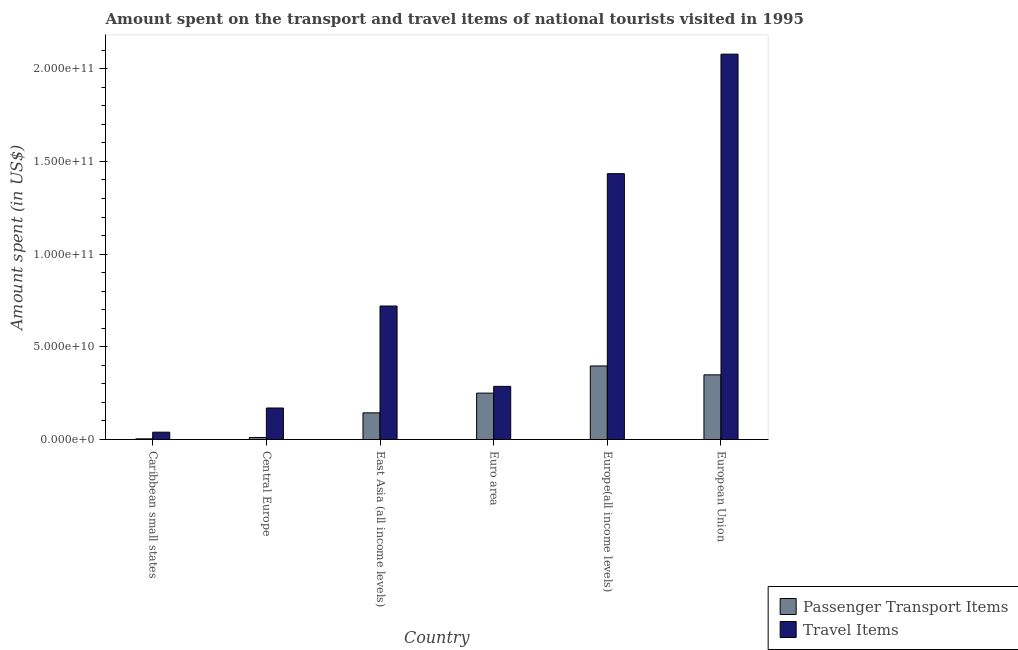How many different coloured bars are there?
Offer a terse response. 2. Are the number of bars per tick equal to the number of legend labels?
Your answer should be very brief. Yes. In how many cases, is the number of bars for a given country not equal to the number of legend labels?
Provide a succinct answer. 0. What is the amount spent in travel items in European Union?
Offer a terse response. 2.08e+11. Across all countries, what is the maximum amount spent on passenger transport items?
Give a very brief answer. 3.97e+1. Across all countries, what is the minimum amount spent in travel items?
Offer a terse response. 3.96e+09. In which country was the amount spent on passenger transport items maximum?
Provide a succinct answer. Europe(all income levels). In which country was the amount spent in travel items minimum?
Offer a terse response. Caribbean small states. What is the total amount spent on passenger transport items in the graph?
Give a very brief answer. 1.15e+11. What is the difference between the amount spent on passenger transport items in Caribbean small states and that in Central Europe?
Your response must be concise. -7.48e+08. What is the difference between the amount spent on passenger transport items in Euro area and the amount spent in travel items in Central Europe?
Offer a very short reply. 8.04e+09. What is the average amount spent in travel items per country?
Your response must be concise. 7.88e+1. What is the difference between the amount spent on passenger transport items and amount spent in travel items in European Union?
Your answer should be compact. -1.73e+11. In how many countries, is the amount spent in travel items greater than 130000000000 US$?
Ensure brevity in your answer.  2. What is the ratio of the amount spent in travel items in East Asia (all income levels) to that in Euro area?
Ensure brevity in your answer.  2.51. Is the difference between the amount spent in travel items in Central Europe and Euro area greater than the difference between the amount spent on passenger transport items in Central Europe and Euro area?
Ensure brevity in your answer.  Yes. What is the difference between the highest and the second highest amount spent in travel items?
Your answer should be compact. 6.45e+1. What is the difference between the highest and the lowest amount spent on passenger transport items?
Your answer should be very brief. 3.93e+1. What does the 1st bar from the left in East Asia (all income levels) represents?
Your answer should be very brief. Passenger Transport Items. What does the 2nd bar from the right in European Union represents?
Offer a terse response. Passenger Transport Items. How many bars are there?
Your answer should be very brief. 12. How many countries are there in the graph?
Offer a terse response. 6. What is the difference between two consecutive major ticks on the Y-axis?
Provide a short and direct response. 5.00e+1. Does the graph contain any zero values?
Offer a terse response. No. Does the graph contain grids?
Make the answer very short. No. Where does the legend appear in the graph?
Offer a terse response. Bottom right. How many legend labels are there?
Provide a succinct answer. 2. How are the legend labels stacked?
Your answer should be compact. Vertical. What is the title of the graph?
Your response must be concise. Amount spent on the transport and travel items of national tourists visited in 1995. What is the label or title of the Y-axis?
Your answer should be very brief. Amount spent (in US$). What is the Amount spent (in US$) in Passenger Transport Items in Caribbean small states?
Give a very brief answer. 3.62e+08. What is the Amount spent (in US$) in Travel Items in Caribbean small states?
Offer a terse response. 3.96e+09. What is the Amount spent (in US$) in Passenger Transport Items in Central Europe?
Keep it short and to the point. 1.11e+09. What is the Amount spent (in US$) in Travel Items in Central Europe?
Ensure brevity in your answer.  1.70e+1. What is the Amount spent (in US$) of Passenger Transport Items in East Asia (all income levels)?
Provide a succinct answer. 1.44e+1. What is the Amount spent (in US$) of Travel Items in East Asia (all income levels)?
Give a very brief answer. 7.20e+1. What is the Amount spent (in US$) of Passenger Transport Items in Euro area?
Ensure brevity in your answer.  2.50e+1. What is the Amount spent (in US$) in Travel Items in Euro area?
Keep it short and to the point. 2.87e+1. What is the Amount spent (in US$) in Passenger Transport Items in Europe(all income levels)?
Your answer should be compact. 3.97e+1. What is the Amount spent (in US$) of Travel Items in Europe(all income levels)?
Your response must be concise. 1.43e+11. What is the Amount spent (in US$) in Passenger Transport Items in European Union?
Give a very brief answer. 3.49e+1. What is the Amount spent (in US$) in Travel Items in European Union?
Your answer should be very brief. 2.08e+11. Across all countries, what is the maximum Amount spent (in US$) in Passenger Transport Items?
Keep it short and to the point. 3.97e+1. Across all countries, what is the maximum Amount spent (in US$) of Travel Items?
Make the answer very short. 2.08e+11. Across all countries, what is the minimum Amount spent (in US$) of Passenger Transport Items?
Offer a very short reply. 3.62e+08. Across all countries, what is the minimum Amount spent (in US$) in Travel Items?
Offer a terse response. 3.96e+09. What is the total Amount spent (in US$) of Passenger Transport Items in the graph?
Your answer should be very brief. 1.15e+11. What is the total Amount spent (in US$) in Travel Items in the graph?
Provide a succinct answer. 4.73e+11. What is the difference between the Amount spent (in US$) of Passenger Transport Items in Caribbean small states and that in Central Europe?
Offer a terse response. -7.48e+08. What is the difference between the Amount spent (in US$) of Travel Items in Caribbean small states and that in Central Europe?
Offer a terse response. -1.30e+1. What is the difference between the Amount spent (in US$) of Passenger Transport Items in Caribbean small states and that in East Asia (all income levels)?
Your answer should be very brief. -1.40e+1. What is the difference between the Amount spent (in US$) of Travel Items in Caribbean small states and that in East Asia (all income levels)?
Make the answer very short. -6.81e+1. What is the difference between the Amount spent (in US$) of Passenger Transport Items in Caribbean small states and that in Euro area?
Provide a succinct answer. -2.47e+1. What is the difference between the Amount spent (in US$) of Travel Items in Caribbean small states and that in Euro area?
Keep it short and to the point. -2.47e+1. What is the difference between the Amount spent (in US$) of Passenger Transport Items in Caribbean small states and that in Europe(all income levels)?
Provide a succinct answer. -3.93e+1. What is the difference between the Amount spent (in US$) of Travel Items in Caribbean small states and that in Europe(all income levels)?
Your answer should be compact. -1.39e+11. What is the difference between the Amount spent (in US$) of Passenger Transport Items in Caribbean small states and that in European Union?
Provide a succinct answer. -3.45e+1. What is the difference between the Amount spent (in US$) in Travel Items in Caribbean small states and that in European Union?
Your answer should be very brief. -2.04e+11. What is the difference between the Amount spent (in US$) in Passenger Transport Items in Central Europe and that in East Asia (all income levels)?
Offer a terse response. -1.33e+1. What is the difference between the Amount spent (in US$) in Travel Items in Central Europe and that in East Asia (all income levels)?
Offer a very short reply. -5.50e+1. What is the difference between the Amount spent (in US$) of Passenger Transport Items in Central Europe and that in Euro area?
Keep it short and to the point. -2.39e+1. What is the difference between the Amount spent (in US$) in Travel Items in Central Europe and that in Euro area?
Make the answer very short. -1.17e+1. What is the difference between the Amount spent (in US$) in Passenger Transport Items in Central Europe and that in Europe(all income levels)?
Offer a terse response. -3.86e+1. What is the difference between the Amount spent (in US$) in Travel Items in Central Europe and that in Europe(all income levels)?
Offer a terse response. -1.26e+11. What is the difference between the Amount spent (in US$) in Passenger Transport Items in Central Europe and that in European Union?
Offer a terse response. -3.38e+1. What is the difference between the Amount spent (in US$) in Travel Items in Central Europe and that in European Union?
Make the answer very short. -1.91e+11. What is the difference between the Amount spent (in US$) of Passenger Transport Items in East Asia (all income levels) and that in Euro area?
Your answer should be compact. -1.06e+1. What is the difference between the Amount spent (in US$) in Travel Items in East Asia (all income levels) and that in Euro area?
Give a very brief answer. 4.33e+1. What is the difference between the Amount spent (in US$) of Passenger Transport Items in East Asia (all income levels) and that in Europe(all income levels)?
Your answer should be compact. -2.53e+1. What is the difference between the Amount spent (in US$) in Travel Items in East Asia (all income levels) and that in Europe(all income levels)?
Make the answer very short. -7.14e+1. What is the difference between the Amount spent (in US$) of Passenger Transport Items in East Asia (all income levels) and that in European Union?
Ensure brevity in your answer.  -2.05e+1. What is the difference between the Amount spent (in US$) of Travel Items in East Asia (all income levels) and that in European Union?
Keep it short and to the point. -1.36e+11. What is the difference between the Amount spent (in US$) of Passenger Transport Items in Euro area and that in Europe(all income levels)?
Keep it short and to the point. -1.47e+1. What is the difference between the Amount spent (in US$) in Travel Items in Euro area and that in Europe(all income levels)?
Offer a very short reply. -1.15e+11. What is the difference between the Amount spent (in US$) of Passenger Transport Items in Euro area and that in European Union?
Offer a very short reply. -9.85e+09. What is the difference between the Amount spent (in US$) of Travel Items in Euro area and that in European Union?
Ensure brevity in your answer.  -1.79e+11. What is the difference between the Amount spent (in US$) of Passenger Transport Items in Europe(all income levels) and that in European Union?
Offer a terse response. 4.80e+09. What is the difference between the Amount spent (in US$) of Travel Items in Europe(all income levels) and that in European Union?
Provide a succinct answer. -6.45e+1. What is the difference between the Amount spent (in US$) in Passenger Transport Items in Caribbean small states and the Amount spent (in US$) in Travel Items in Central Europe?
Ensure brevity in your answer.  -1.66e+1. What is the difference between the Amount spent (in US$) in Passenger Transport Items in Caribbean small states and the Amount spent (in US$) in Travel Items in East Asia (all income levels)?
Ensure brevity in your answer.  -7.16e+1. What is the difference between the Amount spent (in US$) in Passenger Transport Items in Caribbean small states and the Amount spent (in US$) in Travel Items in Euro area?
Your response must be concise. -2.83e+1. What is the difference between the Amount spent (in US$) in Passenger Transport Items in Caribbean small states and the Amount spent (in US$) in Travel Items in Europe(all income levels)?
Your answer should be very brief. -1.43e+11. What is the difference between the Amount spent (in US$) in Passenger Transport Items in Caribbean small states and the Amount spent (in US$) in Travel Items in European Union?
Provide a short and direct response. -2.08e+11. What is the difference between the Amount spent (in US$) in Passenger Transport Items in Central Europe and the Amount spent (in US$) in Travel Items in East Asia (all income levels)?
Offer a very short reply. -7.09e+1. What is the difference between the Amount spent (in US$) of Passenger Transport Items in Central Europe and the Amount spent (in US$) of Travel Items in Euro area?
Offer a very short reply. -2.76e+1. What is the difference between the Amount spent (in US$) of Passenger Transport Items in Central Europe and the Amount spent (in US$) of Travel Items in Europe(all income levels)?
Make the answer very short. -1.42e+11. What is the difference between the Amount spent (in US$) of Passenger Transport Items in Central Europe and the Amount spent (in US$) of Travel Items in European Union?
Keep it short and to the point. -2.07e+11. What is the difference between the Amount spent (in US$) in Passenger Transport Items in East Asia (all income levels) and the Amount spent (in US$) in Travel Items in Euro area?
Your answer should be compact. -1.43e+1. What is the difference between the Amount spent (in US$) in Passenger Transport Items in East Asia (all income levels) and the Amount spent (in US$) in Travel Items in Europe(all income levels)?
Offer a terse response. -1.29e+11. What is the difference between the Amount spent (in US$) of Passenger Transport Items in East Asia (all income levels) and the Amount spent (in US$) of Travel Items in European Union?
Ensure brevity in your answer.  -1.93e+11. What is the difference between the Amount spent (in US$) in Passenger Transport Items in Euro area and the Amount spent (in US$) in Travel Items in Europe(all income levels)?
Your answer should be compact. -1.18e+11. What is the difference between the Amount spent (in US$) in Passenger Transport Items in Euro area and the Amount spent (in US$) in Travel Items in European Union?
Your answer should be compact. -1.83e+11. What is the difference between the Amount spent (in US$) in Passenger Transport Items in Europe(all income levels) and the Amount spent (in US$) in Travel Items in European Union?
Offer a very short reply. -1.68e+11. What is the average Amount spent (in US$) of Passenger Transport Items per country?
Offer a very short reply. 1.92e+1. What is the average Amount spent (in US$) of Travel Items per country?
Your answer should be very brief. 7.88e+1. What is the difference between the Amount spent (in US$) in Passenger Transport Items and Amount spent (in US$) in Travel Items in Caribbean small states?
Your answer should be very brief. -3.59e+09. What is the difference between the Amount spent (in US$) in Passenger Transport Items and Amount spent (in US$) in Travel Items in Central Europe?
Offer a terse response. -1.59e+1. What is the difference between the Amount spent (in US$) of Passenger Transport Items and Amount spent (in US$) of Travel Items in East Asia (all income levels)?
Provide a short and direct response. -5.76e+1. What is the difference between the Amount spent (in US$) of Passenger Transport Items and Amount spent (in US$) of Travel Items in Euro area?
Your response must be concise. -3.65e+09. What is the difference between the Amount spent (in US$) of Passenger Transport Items and Amount spent (in US$) of Travel Items in Europe(all income levels)?
Provide a short and direct response. -1.04e+11. What is the difference between the Amount spent (in US$) of Passenger Transport Items and Amount spent (in US$) of Travel Items in European Union?
Ensure brevity in your answer.  -1.73e+11. What is the ratio of the Amount spent (in US$) of Passenger Transport Items in Caribbean small states to that in Central Europe?
Your answer should be compact. 0.33. What is the ratio of the Amount spent (in US$) of Travel Items in Caribbean small states to that in Central Europe?
Provide a succinct answer. 0.23. What is the ratio of the Amount spent (in US$) of Passenger Transport Items in Caribbean small states to that in East Asia (all income levels)?
Your answer should be very brief. 0.03. What is the ratio of the Amount spent (in US$) in Travel Items in Caribbean small states to that in East Asia (all income levels)?
Provide a succinct answer. 0.05. What is the ratio of the Amount spent (in US$) of Passenger Transport Items in Caribbean small states to that in Euro area?
Your response must be concise. 0.01. What is the ratio of the Amount spent (in US$) in Travel Items in Caribbean small states to that in Euro area?
Give a very brief answer. 0.14. What is the ratio of the Amount spent (in US$) in Passenger Transport Items in Caribbean small states to that in Europe(all income levels)?
Offer a terse response. 0.01. What is the ratio of the Amount spent (in US$) in Travel Items in Caribbean small states to that in Europe(all income levels)?
Provide a short and direct response. 0.03. What is the ratio of the Amount spent (in US$) in Passenger Transport Items in Caribbean small states to that in European Union?
Your response must be concise. 0.01. What is the ratio of the Amount spent (in US$) in Travel Items in Caribbean small states to that in European Union?
Offer a terse response. 0.02. What is the ratio of the Amount spent (in US$) in Passenger Transport Items in Central Europe to that in East Asia (all income levels)?
Provide a short and direct response. 0.08. What is the ratio of the Amount spent (in US$) of Travel Items in Central Europe to that in East Asia (all income levels)?
Provide a short and direct response. 0.24. What is the ratio of the Amount spent (in US$) of Passenger Transport Items in Central Europe to that in Euro area?
Ensure brevity in your answer.  0.04. What is the ratio of the Amount spent (in US$) of Travel Items in Central Europe to that in Euro area?
Provide a short and direct response. 0.59. What is the ratio of the Amount spent (in US$) of Passenger Transport Items in Central Europe to that in Europe(all income levels)?
Offer a terse response. 0.03. What is the ratio of the Amount spent (in US$) in Travel Items in Central Europe to that in Europe(all income levels)?
Give a very brief answer. 0.12. What is the ratio of the Amount spent (in US$) of Passenger Transport Items in Central Europe to that in European Union?
Your answer should be compact. 0.03. What is the ratio of the Amount spent (in US$) in Travel Items in Central Europe to that in European Union?
Your response must be concise. 0.08. What is the ratio of the Amount spent (in US$) in Passenger Transport Items in East Asia (all income levels) to that in Euro area?
Make the answer very short. 0.57. What is the ratio of the Amount spent (in US$) of Travel Items in East Asia (all income levels) to that in Euro area?
Offer a terse response. 2.51. What is the ratio of the Amount spent (in US$) in Passenger Transport Items in East Asia (all income levels) to that in Europe(all income levels)?
Ensure brevity in your answer.  0.36. What is the ratio of the Amount spent (in US$) of Travel Items in East Asia (all income levels) to that in Europe(all income levels)?
Provide a short and direct response. 0.5. What is the ratio of the Amount spent (in US$) in Passenger Transport Items in East Asia (all income levels) to that in European Union?
Offer a terse response. 0.41. What is the ratio of the Amount spent (in US$) of Travel Items in East Asia (all income levels) to that in European Union?
Offer a very short reply. 0.35. What is the ratio of the Amount spent (in US$) of Passenger Transport Items in Euro area to that in Europe(all income levels)?
Provide a short and direct response. 0.63. What is the ratio of the Amount spent (in US$) in Travel Items in Euro area to that in Europe(all income levels)?
Your response must be concise. 0.2. What is the ratio of the Amount spent (in US$) in Passenger Transport Items in Euro area to that in European Union?
Keep it short and to the point. 0.72. What is the ratio of the Amount spent (in US$) in Travel Items in Euro area to that in European Union?
Your answer should be compact. 0.14. What is the ratio of the Amount spent (in US$) in Passenger Transport Items in Europe(all income levels) to that in European Union?
Provide a succinct answer. 1.14. What is the ratio of the Amount spent (in US$) of Travel Items in Europe(all income levels) to that in European Union?
Provide a short and direct response. 0.69. What is the difference between the highest and the second highest Amount spent (in US$) in Passenger Transport Items?
Give a very brief answer. 4.80e+09. What is the difference between the highest and the second highest Amount spent (in US$) in Travel Items?
Make the answer very short. 6.45e+1. What is the difference between the highest and the lowest Amount spent (in US$) in Passenger Transport Items?
Your answer should be compact. 3.93e+1. What is the difference between the highest and the lowest Amount spent (in US$) in Travel Items?
Provide a short and direct response. 2.04e+11. 